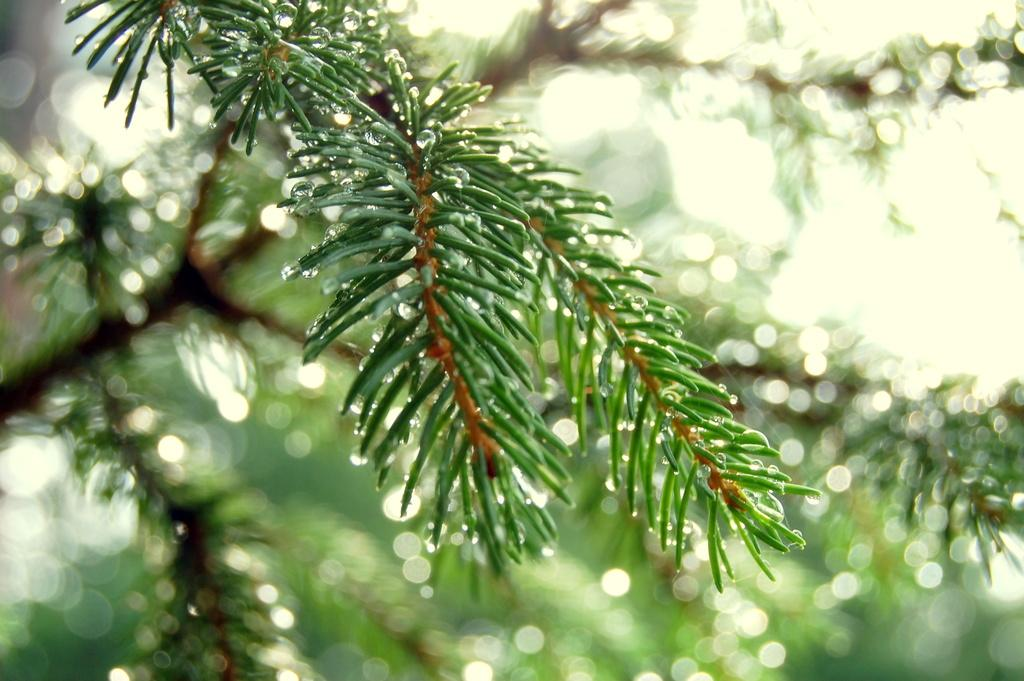What is the main subject in the image? There is a tree in the image. Can you describe the tree's appearance? The tree has water droplets on it. What can be observed about the background of the image? The background of the image is slightly blurred. Can you tell me how many people are trying to join the bed in the image? There is no bed or people present in the image; it features a tree with water droplets and a slightly blurred background. 